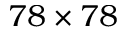<formula> <loc_0><loc_0><loc_500><loc_500>7 8 \times 7 8</formula> 